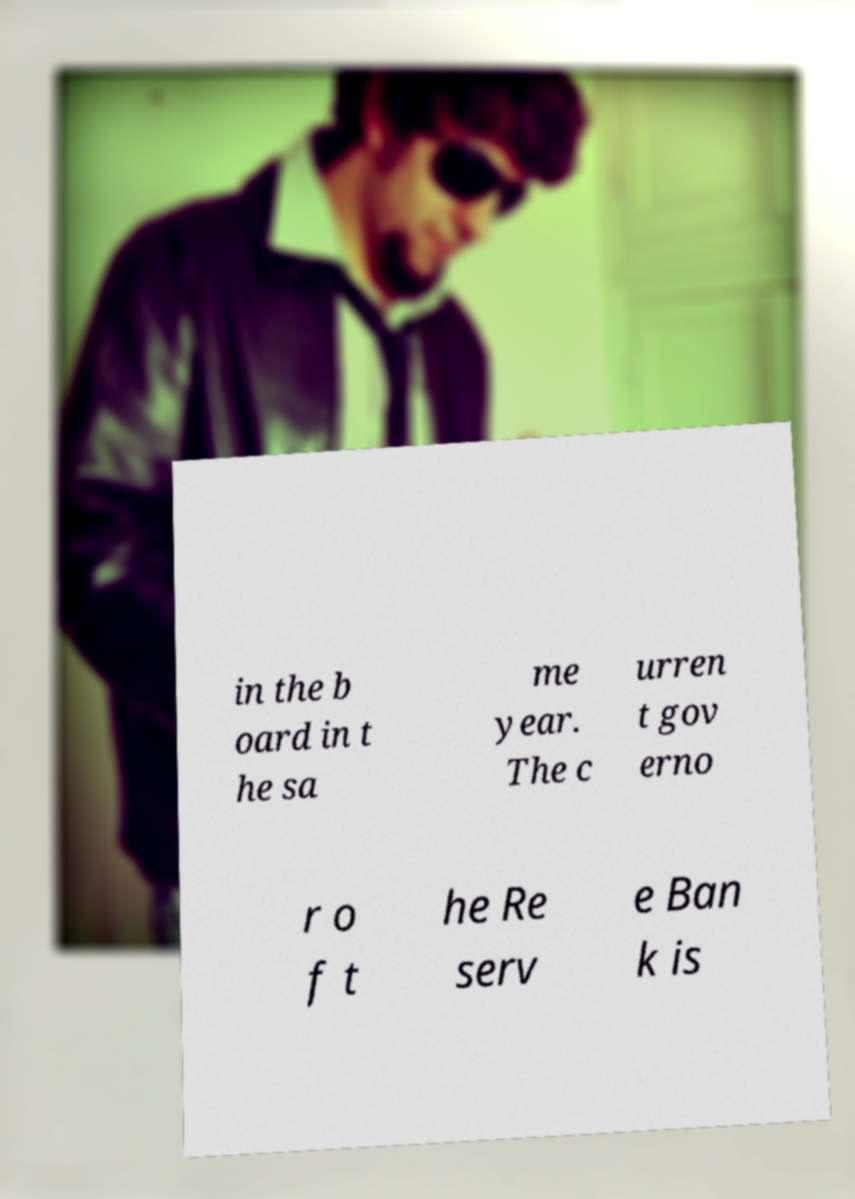Please identify and transcribe the text found in this image. in the b oard in t he sa me year. The c urren t gov erno r o f t he Re serv e Ban k is 